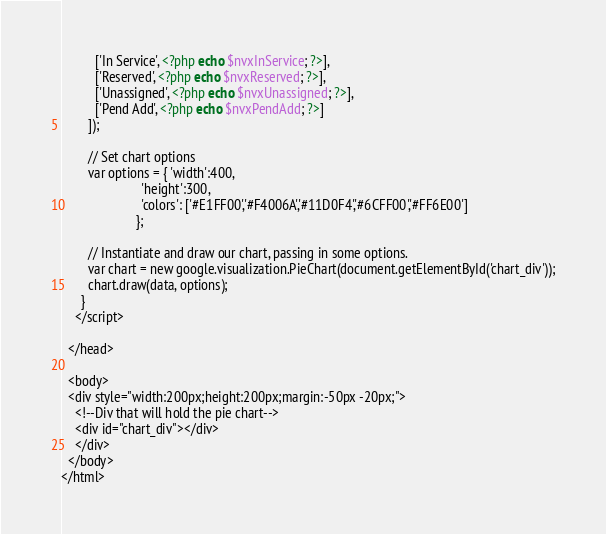<code> <loc_0><loc_0><loc_500><loc_500><_PHP_>          ['In Service', <?php echo $nvxInService; ?>],
          ['Reserved', <?php echo $nvxReserved; ?>],
          ['Unassigned', <?php echo $nvxUnassigned; ?>],
          ['Pend Add', <?php echo $nvxPendAdd; ?>]
        ]);

        // Set chart options
        var options = { 'width':400,
                        'height':300,
					    'colors': ['#E1FF00','#F4006A','#11D0F4','#6CFF00','#FF6E00']
					  };

        // Instantiate and draw our chart, passing in some options.
        var chart = new google.visualization.PieChart(document.getElementById('chart_div'));
        chart.draw(data, options);
      }
    </script>
	
  </head>

  <body>
  <div style="width:200px;height:200px;margin:-50px -20px;">
    <!--Div that will hold the pie chart-->
    <div id="chart_div"></div>
	</div>
  </body>
</html></code> 